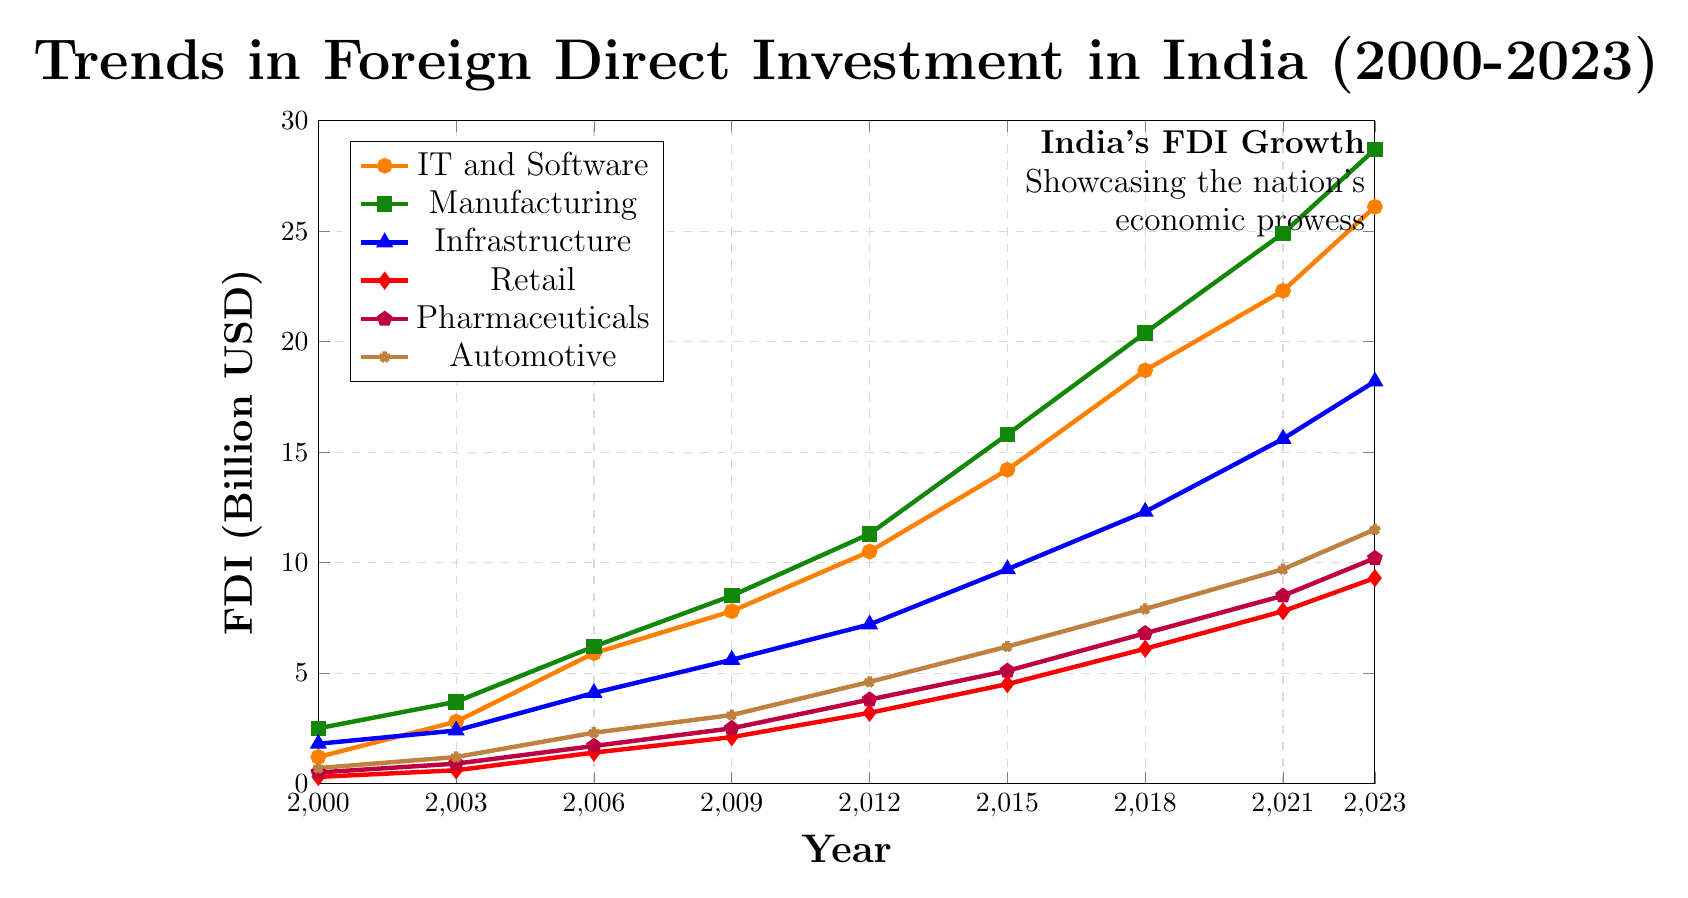What sector had the highest foreign direct investment in 2023? The highest FDI can be identified by the highest point on the y-axis for 2023. Manufacturing reaches 28.7 billion USD.
Answer: Manufacturing How did FDI in Retail change from 2000 to 2023? Reviewing the y-axis value for Retail in 2000 and 2023 shows an increase from 0.3 billion USD to 9.3 billion USD. The change is calculated as 9.3 - 0.3 = 9.0 billion USD.
Answer: 9.0 billion USD Between IT and Software and Automotive sectors, which experienced the higher overall increase in FDI from 2000 to 2023? For IT and Software, the increase is 26.1 - 1.2 = 24.9 billion USD. For Automotive, the increase is 11.5 - 0.7 = 10.8 billion USD. Thus, IT and Software had a higher increase.
Answer: IT and Software How much more was the FDI in Pharmaceuticals than in Retail in 2021? The FDI for Pharmaceuticals in 2021 is 8.5 billion USD and in Retail it is 7.8 billion USD, so the difference is 8.5 - 7.8 = 0.7 billion USD.
Answer: 0.7 billion USD What was the average FDI in Manufacturing from 2000 to 2023? Sum up the values of Manufacturing from each year and divide by the number of data points: (2.5 + 3.7 + 6.2 + 8.5 + 11.3 + 15.8 + 20.4 + 24.9 + 28.7) / 9 = 13.5 billion USD.
Answer: 13.5 billion USD Which sectors' FDI showed the closest values in 2015? By examining 2015 values: IT and Software (14.2), Manufacturing (15.8), Infrastructure (9.7), Retail (4.5), Pharmaceuticals (5.1), Automotive (6.2), the closest values are Pharmaceuticals (5.1) and Automotive (6.2) with a difference of 1.1 billion USD.
Answer: Pharmaceuticals and Automotive Did any sector's FDI double from 2006 to 2009? Checking each sector's FDI from 2006 to 2009: IT and Software (5.9 to 7.8), Manufacturing (6.2 to 8.5), Infrastructure (4.1 to 5.6), Retail (1.4 to 2.1), Pharmaceuticals (1.7 to 2.5), Automotive (2.3 to 3.1). Each calculated difference shows none doubled.
Answer: No Which sector had the least growth in FDI from 2000 to 2023? By calculating the difference for each sector: IT and Software (24.9), Manufacturing (26.2), Infrastructure (16.4), Retail (9.0), Pharmaceuticals (9.7), Automotive (10.8). Retail had the least growth.
Answer: Retail How does the trend in Infrastructure compare to Pharmaceuticals from 2012 to 2023? Observing the trend for Infrastructure, it increased from 7.2 to 18.2 billion USD. Pharmaceuticals increased from 3.8 to 10.2 billion USD. While both sectors show an upward trend, Infrastructure's FDI increased more sharply by 11.0 billion USD compared to Pharmaceuticals' 6.4 billion USD.
Answer: Infrastructure increased more sharply 